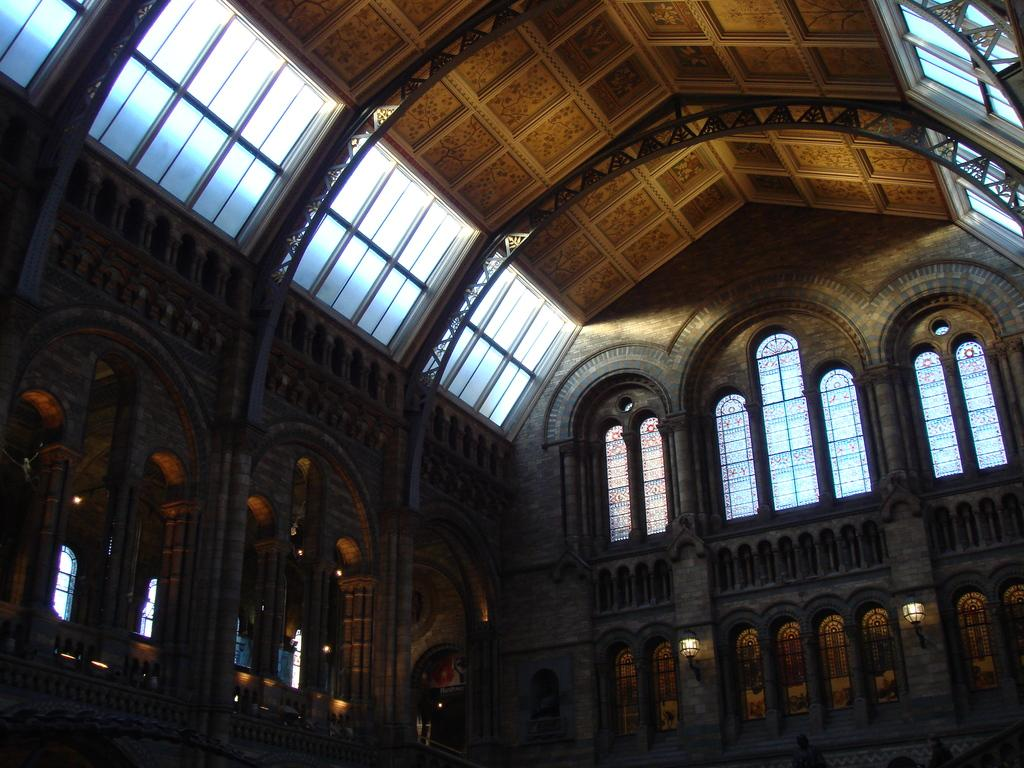What type of location is depicted in the image? The image is of the inside of a building. What architectural features can be seen in the image? There are windows and pillars visible in the image. What part of the building is visible in the image? The ceiling is visible in the image. How many locks can be seen on the windows in the image? There are no locks visible on the windows in the image. What type of men are present in the image? There are no men present in the image. 